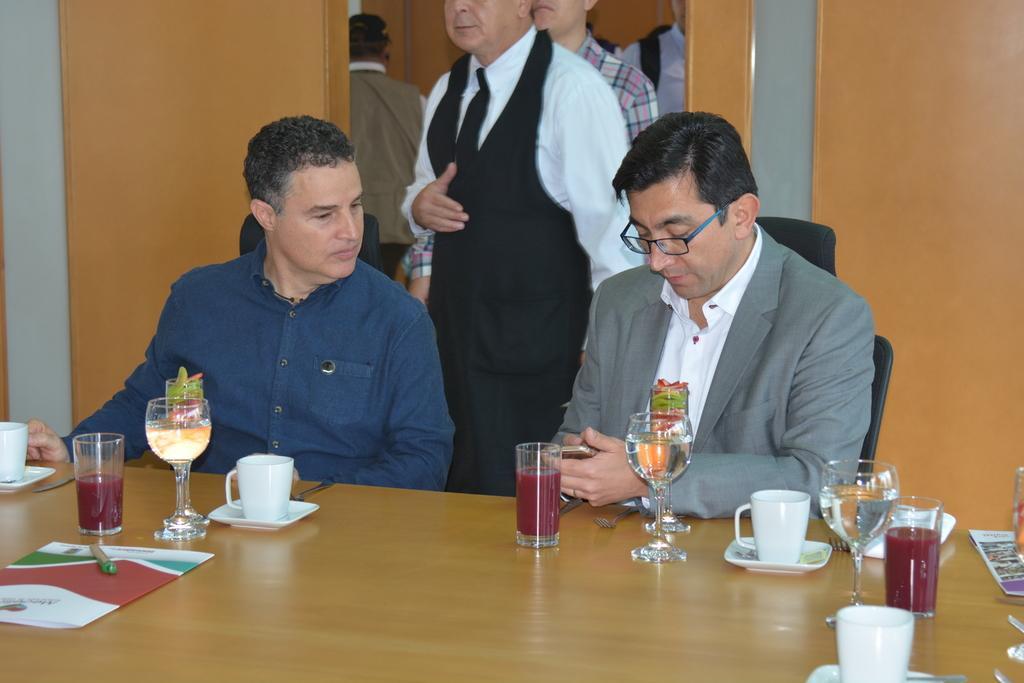Please provide a concise description of this image. In this image there are a few people sitting, one of them is holding a mobile and looking into it, in front of them there is a table with drinks, cups, glasses, paper, pen and other objects, there are a few other people standing and there is a wall 